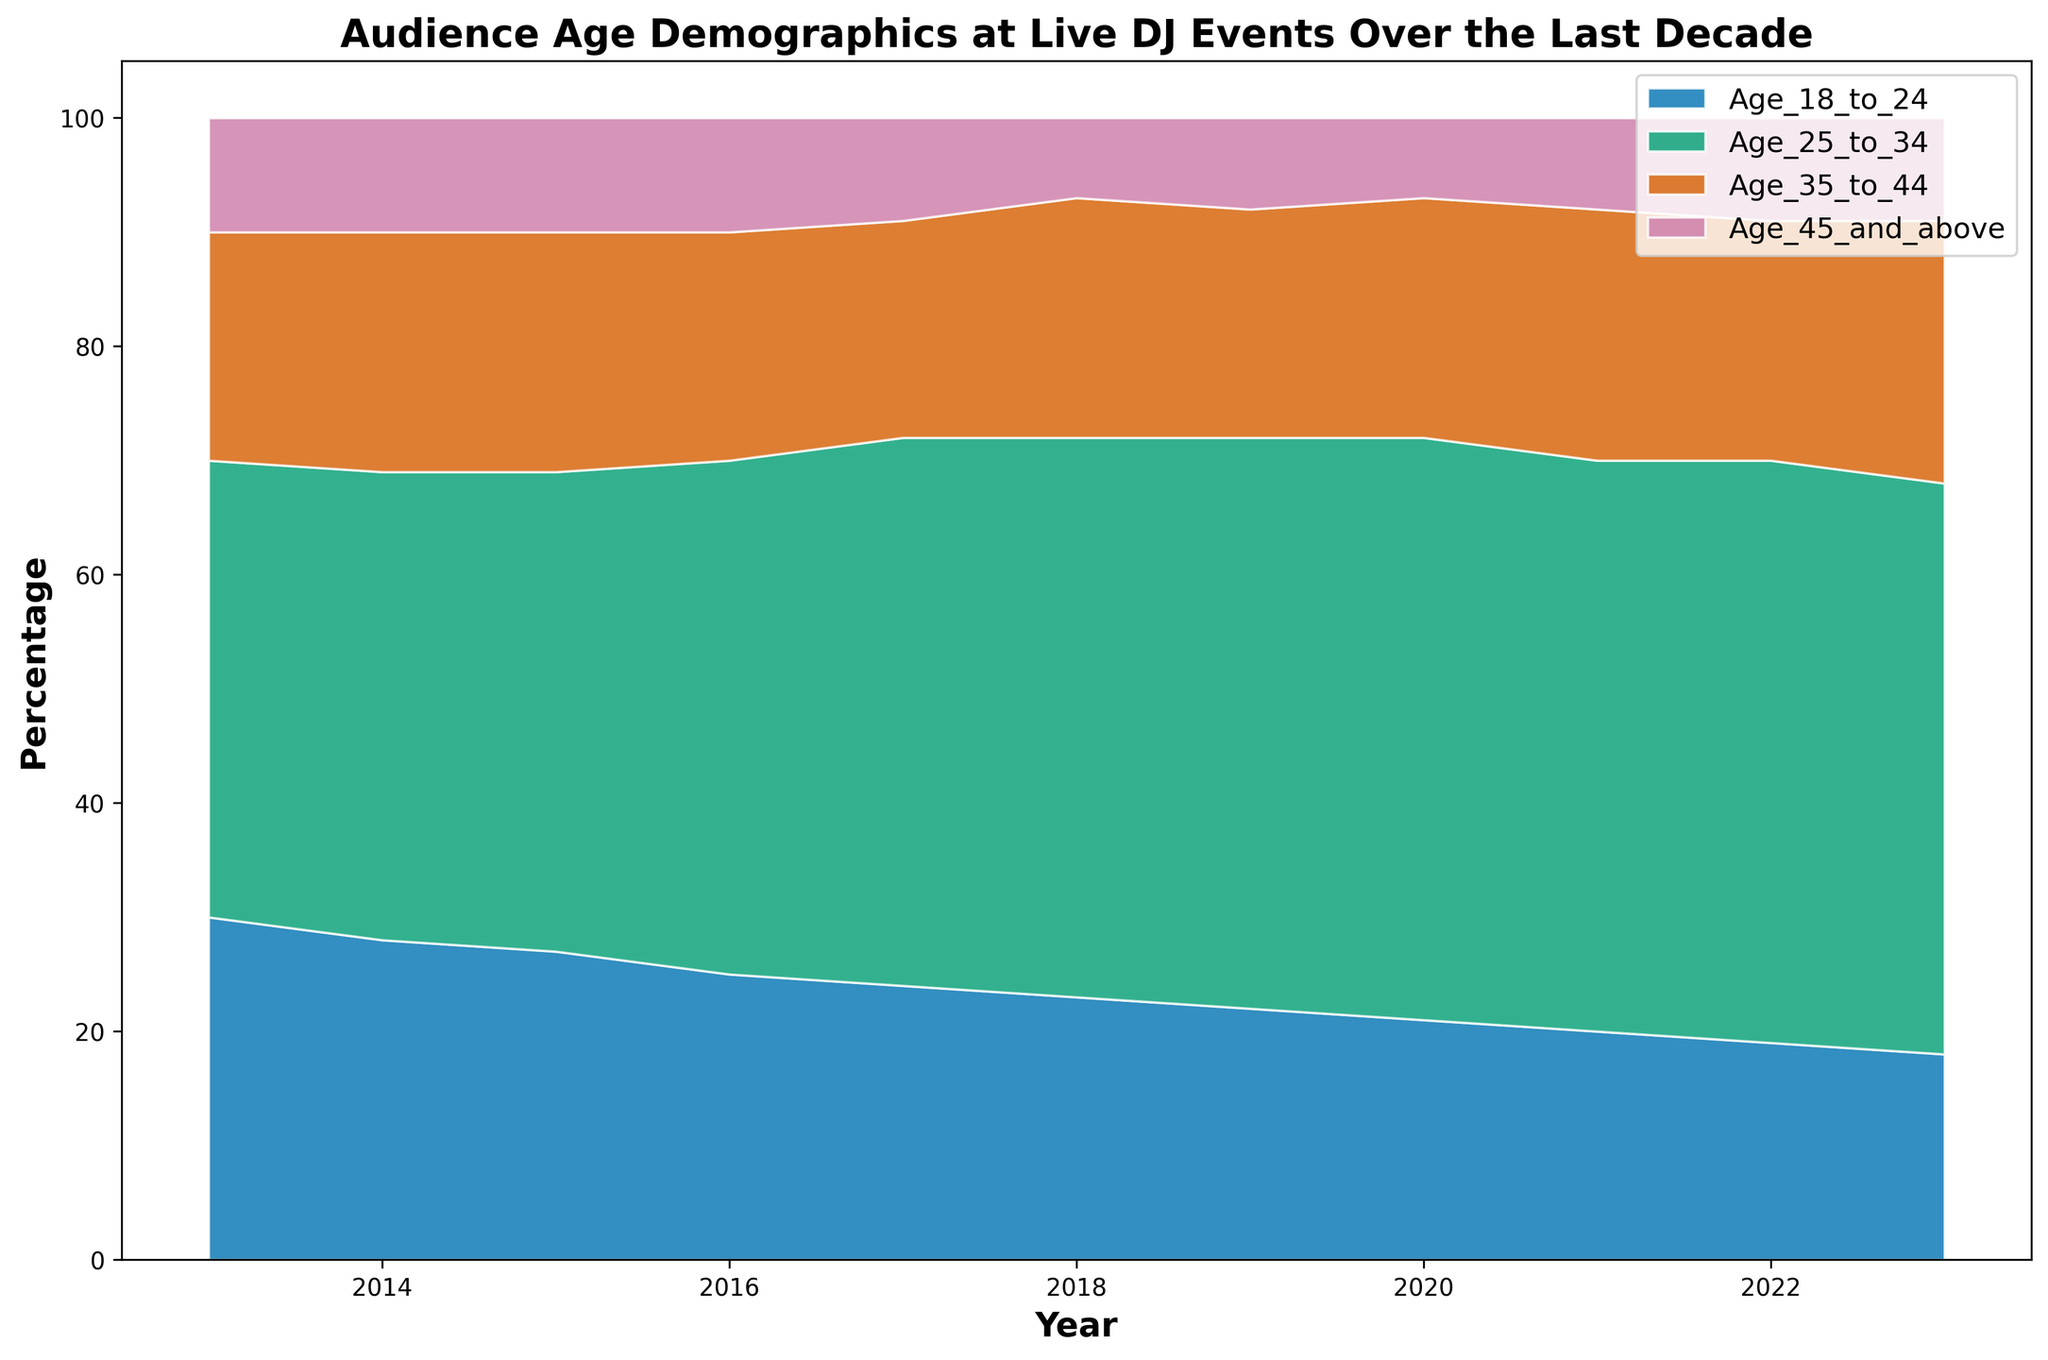What age group shows the highest percentage in 2023? Observe the highest area in 2023, which belongs to the Age_25_to_34 group
Answer: Age_25_to_34 How did the percentage of the Age_18_to_24 group change from 2013 to 2023? Note the values for Age_18_to_24 in 2013 (30%) and 2023 (18%) and calculate the difference: 30% - 18% = 12%
Answer: Decreased by 12% In what year did the Age_25_to_34 group have its highest percentage? Look for the peak of the Age_25_to_34 area, which is around 2022
Answer: 2022 Which age group has shown the most constant percentage throughout the decade? Observe the areas with little height variation over the years, which is the Age_45_and_above group
Answer: Age_45_and_above What is the trend of the percentage for the Age_35_to_44 group from 2016 to 2023? Starting at 20% in 2016, the values gradually increase to 23% in 2023, indicating an upward trend
Answer: Increasing Compare the percentages of Age_18_to_24 and Age_25_to_34 in 2015. Which was higher? Check the heights for 2015: Age_18_to_24 was 27% and Age_25_to_34 was 42%
Answer: Age_25_to_34 What is the sum of the percentages of Age_18_to_24 and Age_45_and_above in 2020? Add the values for 2020: 21% (Age_18_to_24) + 7% (Age_45_and_above) = 28%
Answer: 28% By how much did the percentage of the Age_35_to_44 group change from 2021 to 2022? The values are 22% in 2021 and 21% in 2022, so the difference is 1%
Answer: Decreased by 1% Which age group had the smallest percentage in 2017? Observe the lowest area in 2017, which is Age_45_and_above at 9%
Answer: Age_45_and_above What can you conclude about the trend in the Age_25_to_34 group's percentage from 2013 to 2023? The percentage steadily increases from 40% in 2013 to around 50% in recent years, indicating a consistent upward trend
Answer: Increasing 